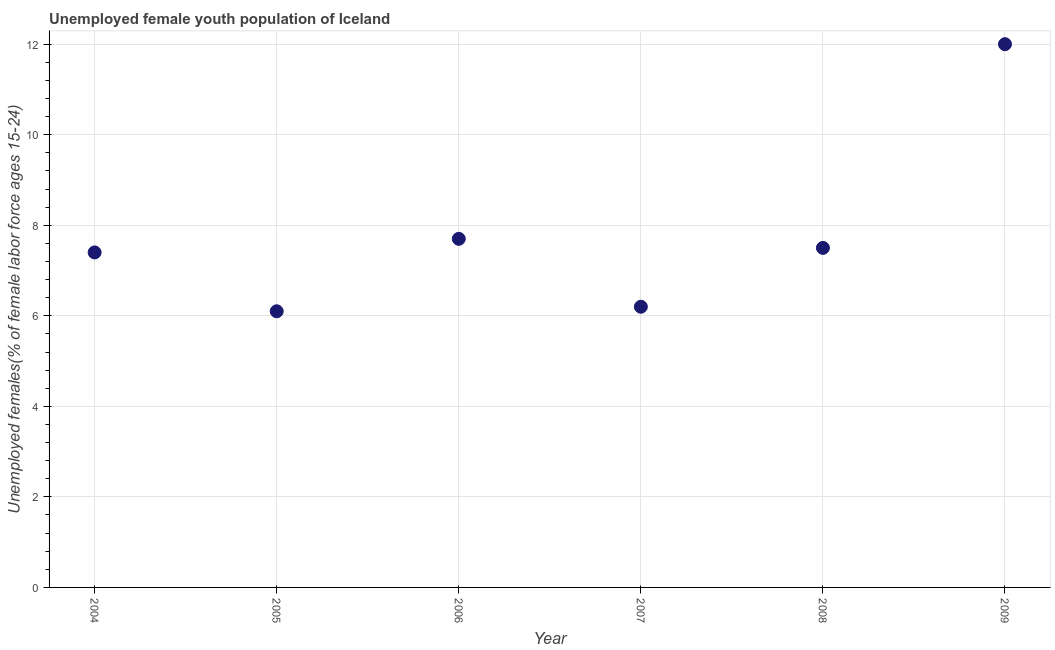What is the unemployed female youth in 2005?
Ensure brevity in your answer.  6.1. Across all years, what is the minimum unemployed female youth?
Ensure brevity in your answer.  6.1. In which year was the unemployed female youth minimum?
Provide a short and direct response. 2005. What is the sum of the unemployed female youth?
Offer a very short reply. 46.9. What is the difference between the unemployed female youth in 2007 and 2008?
Offer a terse response. -1.3. What is the average unemployed female youth per year?
Provide a succinct answer. 7.82. What is the median unemployed female youth?
Make the answer very short. 7.45. What is the ratio of the unemployed female youth in 2004 to that in 2006?
Offer a very short reply. 0.96. What is the difference between the highest and the second highest unemployed female youth?
Keep it short and to the point. 4.3. What is the difference between the highest and the lowest unemployed female youth?
Ensure brevity in your answer.  5.9. In how many years, is the unemployed female youth greater than the average unemployed female youth taken over all years?
Provide a short and direct response. 1. How many dotlines are there?
Make the answer very short. 1. How many years are there in the graph?
Your answer should be compact. 6. Does the graph contain any zero values?
Your answer should be compact. No. What is the title of the graph?
Your answer should be very brief. Unemployed female youth population of Iceland. What is the label or title of the Y-axis?
Provide a short and direct response. Unemployed females(% of female labor force ages 15-24). What is the Unemployed females(% of female labor force ages 15-24) in 2004?
Your answer should be very brief. 7.4. What is the Unemployed females(% of female labor force ages 15-24) in 2005?
Keep it short and to the point. 6.1. What is the Unemployed females(% of female labor force ages 15-24) in 2006?
Offer a terse response. 7.7. What is the Unemployed females(% of female labor force ages 15-24) in 2007?
Give a very brief answer. 6.2. What is the Unemployed females(% of female labor force ages 15-24) in 2009?
Give a very brief answer. 12. What is the difference between the Unemployed females(% of female labor force ages 15-24) in 2004 and 2006?
Provide a short and direct response. -0.3. What is the difference between the Unemployed females(% of female labor force ages 15-24) in 2005 and 2006?
Offer a very short reply. -1.6. What is the difference between the Unemployed females(% of female labor force ages 15-24) in 2005 and 2007?
Your answer should be compact. -0.1. What is the difference between the Unemployed females(% of female labor force ages 15-24) in 2005 and 2008?
Offer a very short reply. -1.4. What is the difference between the Unemployed females(% of female labor force ages 15-24) in 2005 and 2009?
Your response must be concise. -5.9. What is the difference between the Unemployed females(% of female labor force ages 15-24) in 2006 and 2007?
Ensure brevity in your answer.  1.5. What is the difference between the Unemployed females(% of female labor force ages 15-24) in 2006 and 2008?
Offer a terse response. 0.2. What is the difference between the Unemployed females(% of female labor force ages 15-24) in 2006 and 2009?
Your answer should be compact. -4.3. What is the difference between the Unemployed females(% of female labor force ages 15-24) in 2007 and 2008?
Your answer should be compact. -1.3. What is the difference between the Unemployed females(% of female labor force ages 15-24) in 2007 and 2009?
Keep it short and to the point. -5.8. What is the difference between the Unemployed females(% of female labor force ages 15-24) in 2008 and 2009?
Ensure brevity in your answer.  -4.5. What is the ratio of the Unemployed females(% of female labor force ages 15-24) in 2004 to that in 2005?
Provide a short and direct response. 1.21. What is the ratio of the Unemployed females(% of female labor force ages 15-24) in 2004 to that in 2007?
Ensure brevity in your answer.  1.19. What is the ratio of the Unemployed females(% of female labor force ages 15-24) in 2004 to that in 2008?
Provide a succinct answer. 0.99. What is the ratio of the Unemployed females(% of female labor force ages 15-24) in 2004 to that in 2009?
Make the answer very short. 0.62. What is the ratio of the Unemployed females(% of female labor force ages 15-24) in 2005 to that in 2006?
Provide a short and direct response. 0.79. What is the ratio of the Unemployed females(% of female labor force ages 15-24) in 2005 to that in 2008?
Provide a short and direct response. 0.81. What is the ratio of the Unemployed females(% of female labor force ages 15-24) in 2005 to that in 2009?
Your response must be concise. 0.51. What is the ratio of the Unemployed females(% of female labor force ages 15-24) in 2006 to that in 2007?
Your answer should be compact. 1.24. What is the ratio of the Unemployed females(% of female labor force ages 15-24) in 2006 to that in 2009?
Provide a succinct answer. 0.64. What is the ratio of the Unemployed females(% of female labor force ages 15-24) in 2007 to that in 2008?
Offer a very short reply. 0.83. What is the ratio of the Unemployed females(% of female labor force ages 15-24) in 2007 to that in 2009?
Offer a very short reply. 0.52. What is the ratio of the Unemployed females(% of female labor force ages 15-24) in 2008 to that in 2009?
Offer a terse response. 0.62. 